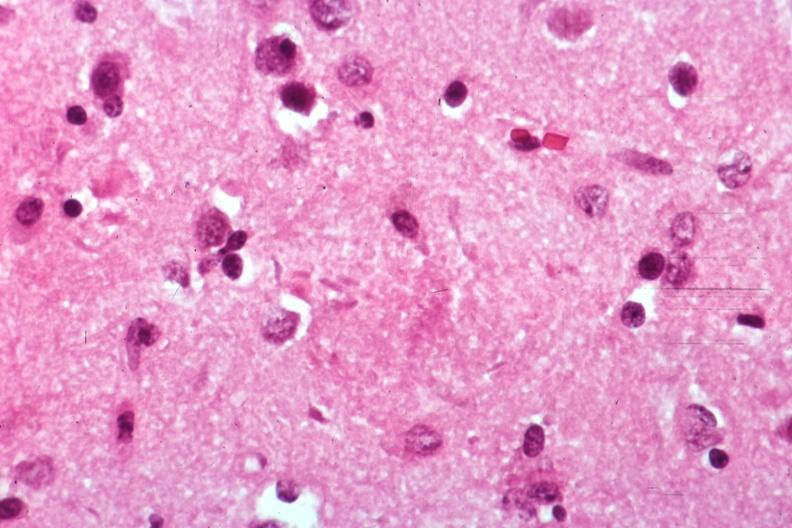does this image show neural tangle?
Answer the question using a single word or phrase. Yes 